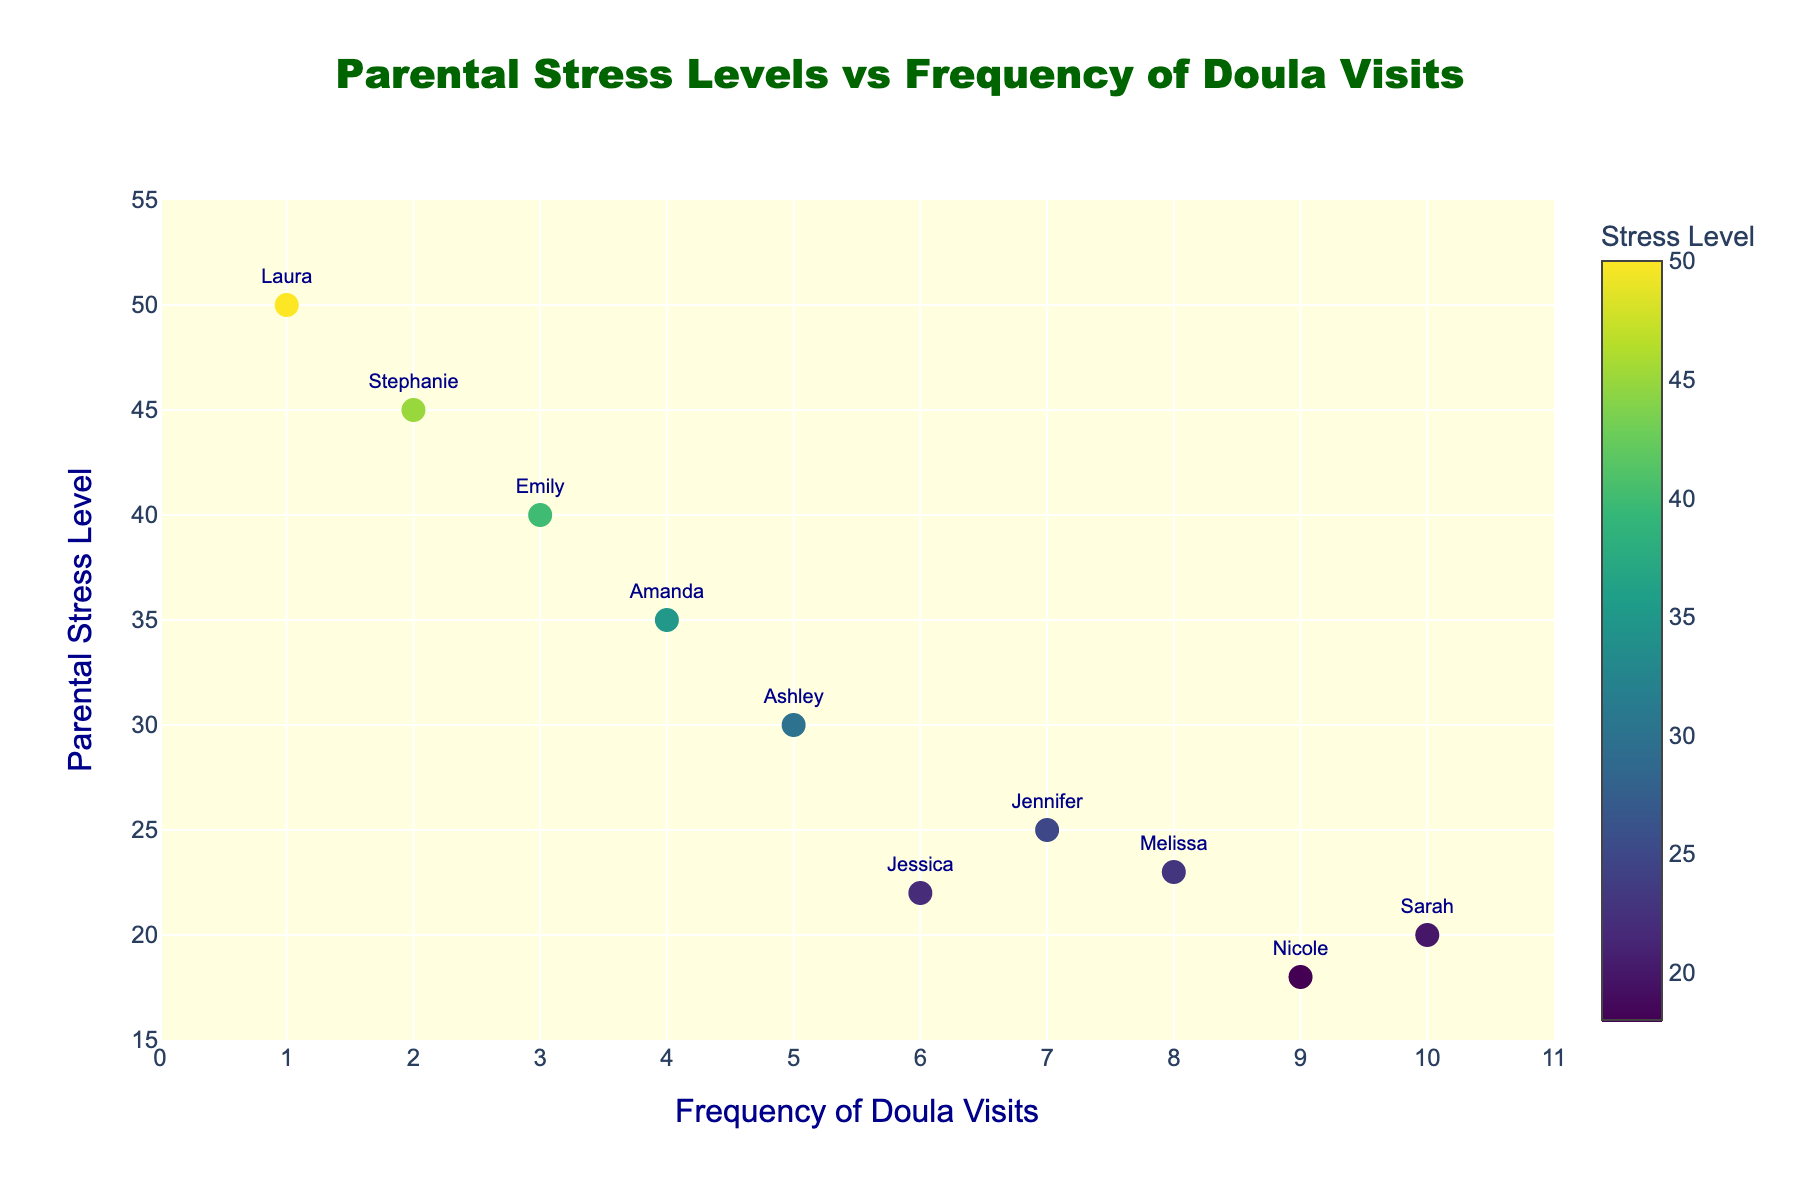How many mothers are represented in the plot? The plot contains a data point for each mother, and there are ten names displayed next to the data points.
Answer: 10 What is the title of the plot? The title is shown at the top of the plot, clearly indicating what the plot represents.
Answer: Parental Stress Levels vs Frequency of Doula Visits What is the color bar on the right side of the plot representing? The color bar is labeled as 'Stress Level', and it shows the range of parental stress levels, which correlate with the colors of the data points.
Answer: Stress Level Which mother has the highest parental stress level? By examining the y-axis and looking for the highest point on the plot, this data point will have the name "Laura" next to it.
Answer: Laura How many times did Sarah visit the doula? By finding Sarah's name on the plot, we can see her corresponding x-axis value, which is 10.
Answer: 10 Which mother has the lowest parental stress level? By checking the lowest point on the y-axis, we find the data point labeled "Nicole".
Answer: Nicole Compare the stress levels of Amanda and Melissa. Who has a lower stress level? Amanda corresponds to a stress level of 35, and Melissa corresponds to a stress level of 23. Since 23 is less than 35, Melissa has a lower stress level.
Answer: Melissa What's the average parental stress level? Sum all the stress levels: 30+25+40+20+22+35+23+45+18+50=308. Divide by the number of mothers (10): 308/10=30.8.
Answer: 30.8 Which mothers had a frequency of doula visits above the average? The average frequency can be calculated as: (5+7+3+10+6+4+8+2+9+1)/10 = 5.5. According to the plot, Jennifer, Sarah, Melissa, and Nicole had visits above 5.5.
Answer: Jennifer, Sarah, Melissa, Nicole What pattern is noticeable between the frequency of doula visits and parental stress levels? Observing the pattern, it becomes clear that higher frequencies of doula visits generally correspond with lower parental stress levels.
Answer: Higher doula visits correlate with lower stress levels 